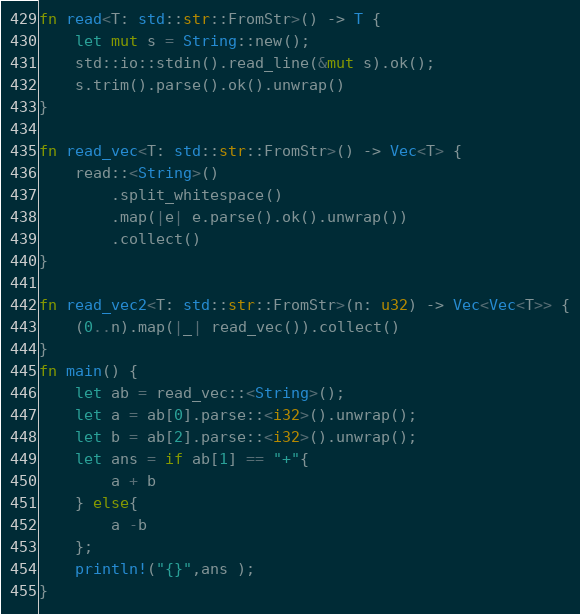<code> <loc_0><loc_0><loc_500><loc_500><_Rust_>fn read<T: std::str::FromStr>() -> T {
    let mut s = String::new();
    std::io::stdin().read_line(&mut s).ok();
    s.trim().parse().ok().unwrap()
}

fn read_vec<T: std::str::FromStr>() -> Vec<T> {
    read::<String>()
        .split_whitespace()
        .map(|e| e.parse().ok().unwrap())
        .collect()
}

fn read_vec2<T: std::str::FromStr>(n: u32) -> Vec<Vec<T>> {
    (0..n).map(|_| read_vec()).collect()
}
fn main() {
    let ab = read_vec::<String>();
    let a = ab[0].parse::<i32>().unwrap();
    let b = ab[2].parse::<i32>().unwrap();
    let ans = if ab[1] == "+"{
        a + b
    } else{
        a -b 
    };
    println!("{}",ans );
}</code> 